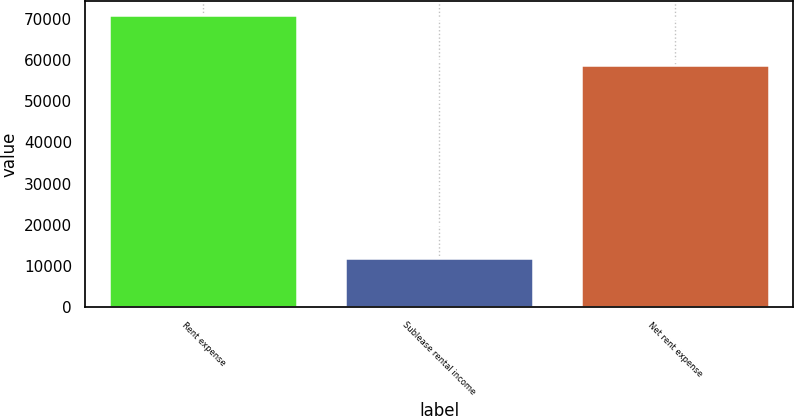Convert chart to OTSL. <chart><loc_0><loc_0><loc_500><loc_500><bar_chart><fcel>Rent expense<fcel>Sublease rental income<fcel>Net rent expense<nl><fcel>70815<fcel>12007<fcel>58808<nl></chart> 